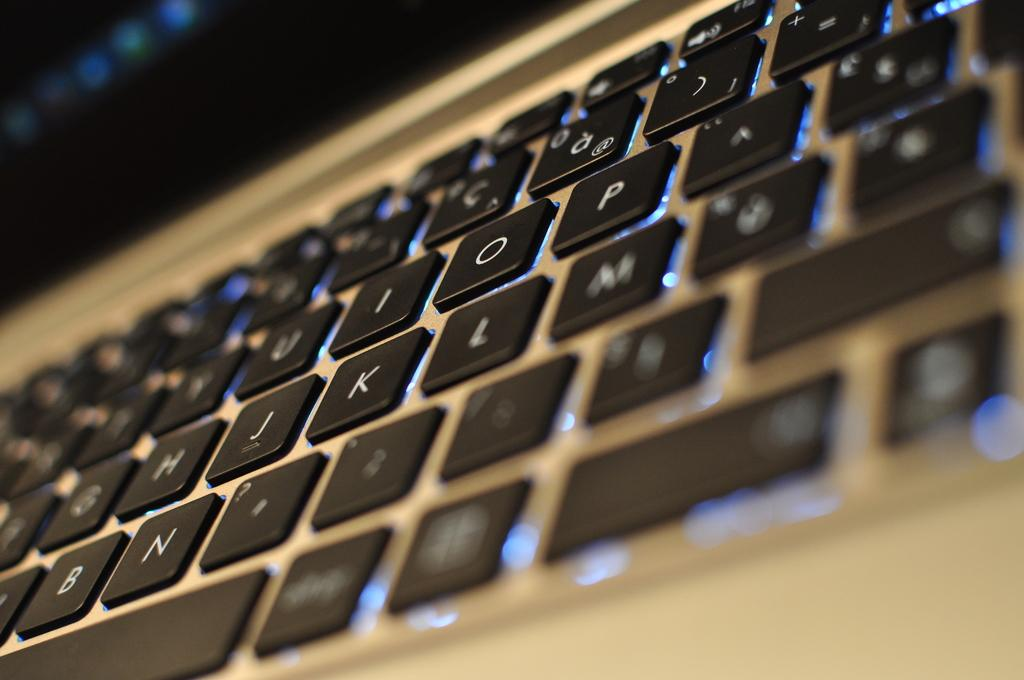Provide a one-sentence caption for the provided image. A keyboard with the keypad I, O, P, J, K and L prominently showing. 